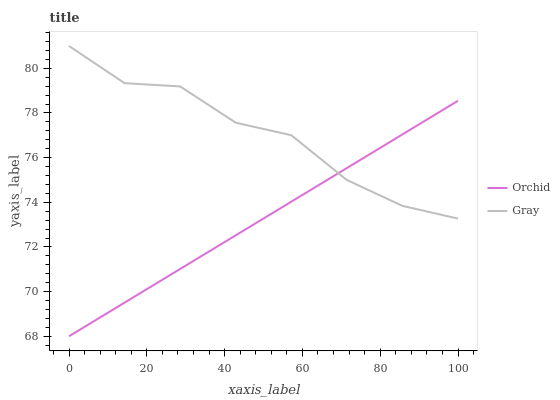Does Orchid have the minimum area under the curve?
Answer yes or no. Yes. Does Gray have the maximum area under the curve?
Answer yes or no. Yes. Does Orchid have the maximum area under the curve?
Answer yes or no. No. Is Orchid the smoothest?
Answer yes or no. Yes. Is Gray the roughest?
Answer yes or no. Yes. Is Orchid the roughest?
Answer yes or no. No. Does Gray have the highest value?
Answer yes or no. Yes. Does Orchid have the highest value?
Answer yes or no. No. Does Orchid intersect Gray?
Answer yes or no. Yes. Is Orchid less than Gray?
Answer yes or no. No. Is Orchid greater than Gray?
Answer yes or no. No. 